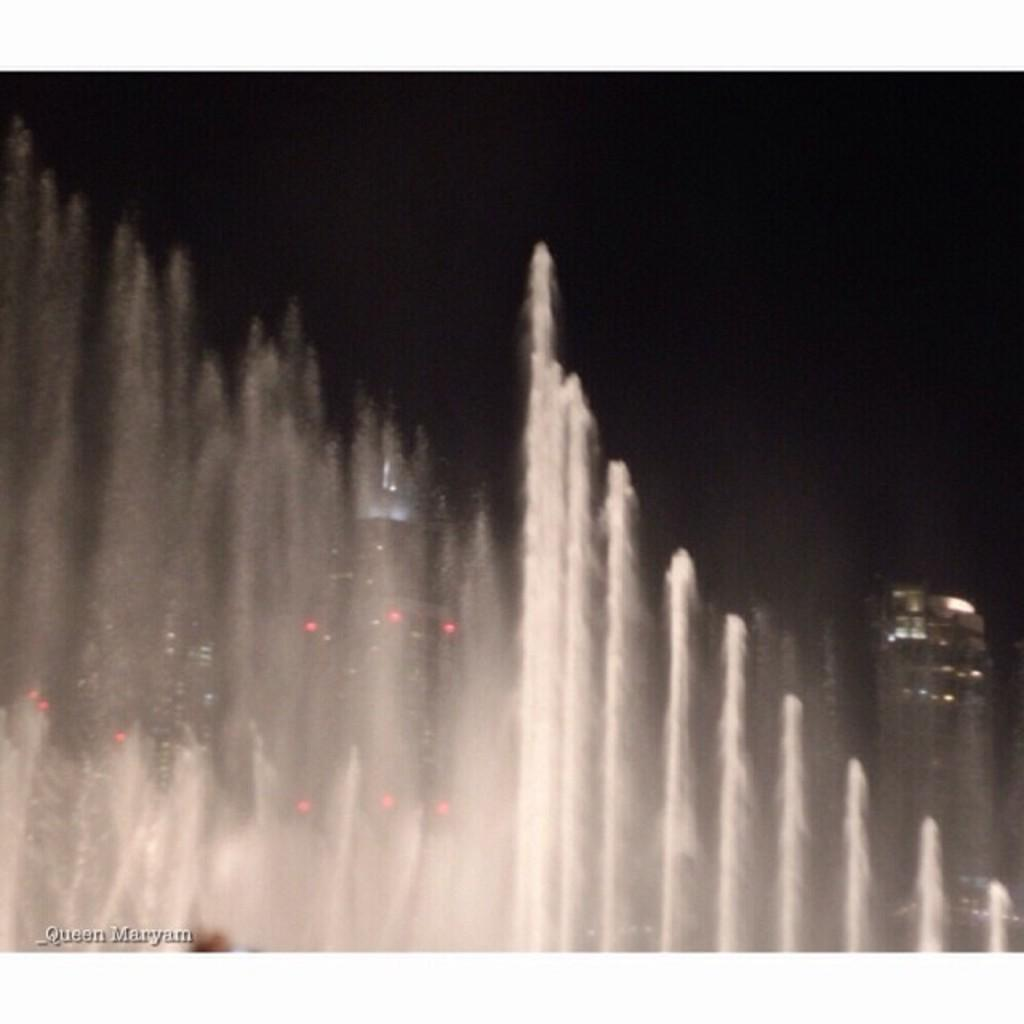What is the main subject in the front of the image? There is a water-fountain in the front of the image. What can be seen in the background of the image? There are buildings in the background of the image. How would you describe the sky in the background of the image? The sky is dark in the background of the image. Is there any additional information or marking on the image? Yes, there is a watermark at the bottom left side of the image. Can you see any cherries falling from the sky in the image? No, there are no cherries or any indication of falling cherries in the image. Is there a bun visible in the image? No, there is no bun present in the image. 